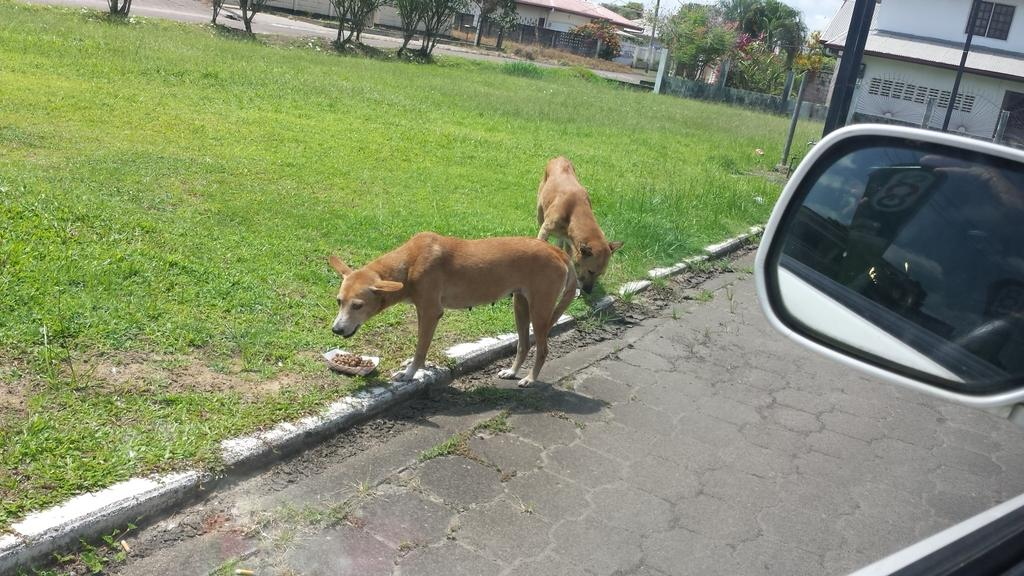How many dogs are present in the image? There are two dogs in the image. What else can be seen in the image besides the dogs? There is a vehicle in the image. What can be seen in the background of the image? There are buildings, trees, and the sky visible in the background of the image. Where is the throne located in the image? There is no throne present in the image. Can you describe the type of cracker that the dogs are eating in the image? There are no crackers present in the image, and the dogs are not eating anything. 